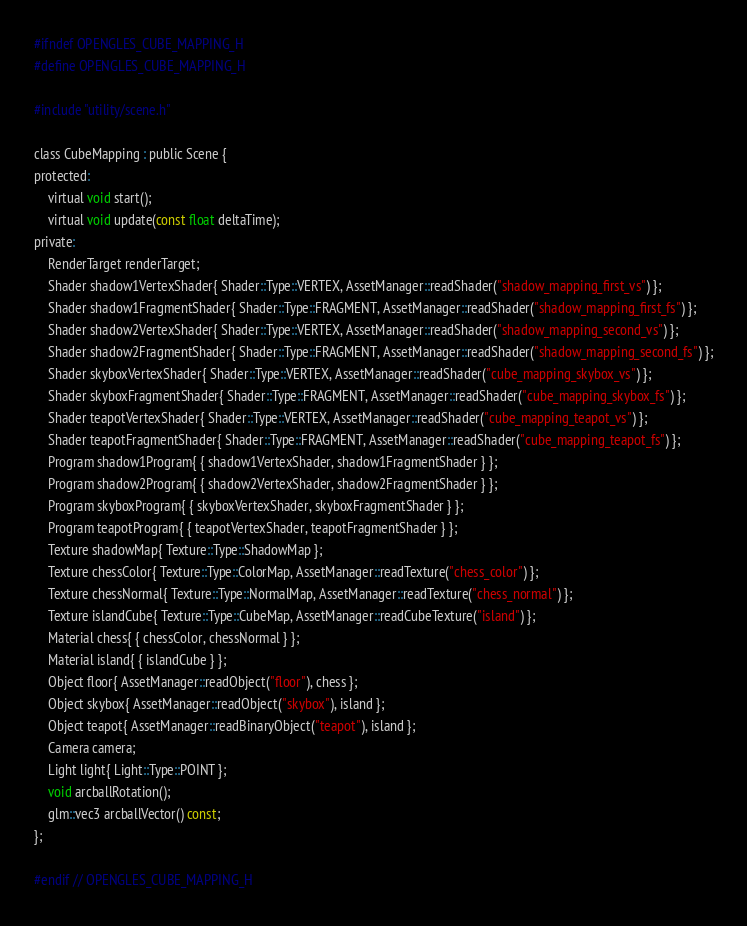<code> <loc_0><loc_0><loc_500><loc_500><_C_>#ifndef OPENGLES_CUBE_MAPPING_H
#define OPENGLES_CUBE_MAPPING_H

#include "utility/scene.h"

class CubeMapping : public Scene {
protected:
    virtual void start();
    virtual void update(const float deltaTime);
private:
    RenderTarget renderTarget;
    Shader shadow1VertexShader{ Shader::Type::VERTEX, AssetManager::readShader("shadow_mapping_first_vs") };
    Shader shadow1FragmentShader{ Shader::Type::FRAGMENT, AssetManager::readShader("shadow_mapping_first_fs") };
    Shader shadow2VertexShader{ Shader::Type::VERTEX, AssetManager::readShader("shadow_mapping_second_vs") };
    Shader shadow2FragmentShader{ Shader::Type::FRAGMENT, AssetManager::readShader("shadow_mapping_second_fs") };
    Shader skyboxVertexShader{ Shader::Type::VERTEX, AssetManager::readShader("cube_mapping_skybox_vs") };
    Shader skyboxFragmentShader{ Shader::Type::FRAGMENT, AssetManager::readShader("cube_mapping_skybox_fs") };
    Shader teapotVertexShader{ Shader::Type::VERTEX, AssetManager::readShader("cube_mapping_teapot_vs") };
    Shader teapotFragmentShader{ Shader::Type::FRAGMENT, AssetManager::readShader("cube_mapping_teapot_fs") };
    Program shadow1Program{ { shadow1VertexShader, shadow1FragmentShader } };
    Program shadow2Program{ { shadow2VertexShader, shadow2FragmentShader } };
    Program skyboxProgram{ { skyboxVertexShader, skyboxFragmentShader } };
    Program teapotProgram{ { teapotVertexShader, teapotFragmentShader } };
    Texture shadowMap{ Texture::Type::ShadowMap };
    Texture chessColor{ Texture::Type::ColorMap, AssetManager::readTexture("chess_color") };
    Texture chessNormal{ Texture::Type::NormalMap, AssetManager::readTexture("chess_normal") };
    Texture islandCube{ Texture::Type::CubeMap, AssetManager::readCubeTexture("island") };
    Material chess{ { chessColor, chessNormal } };
    Material island{ { islandCube } };
    Object floor{ AssetManager::readObject("floor"), chess };
    Object skybox{ AssetManager::readObject("skybox"), island };
    Object teapot{ AssetManager::readBinaryObject("teapot"), island };
    Camera camera;
    Light light{ Light::Type::POINT };
    void arcballRotation();
    glm::vec3 arcballVector() const;
};

#endif // OPENGLES_CUBE_MAPPING_H
</code> 